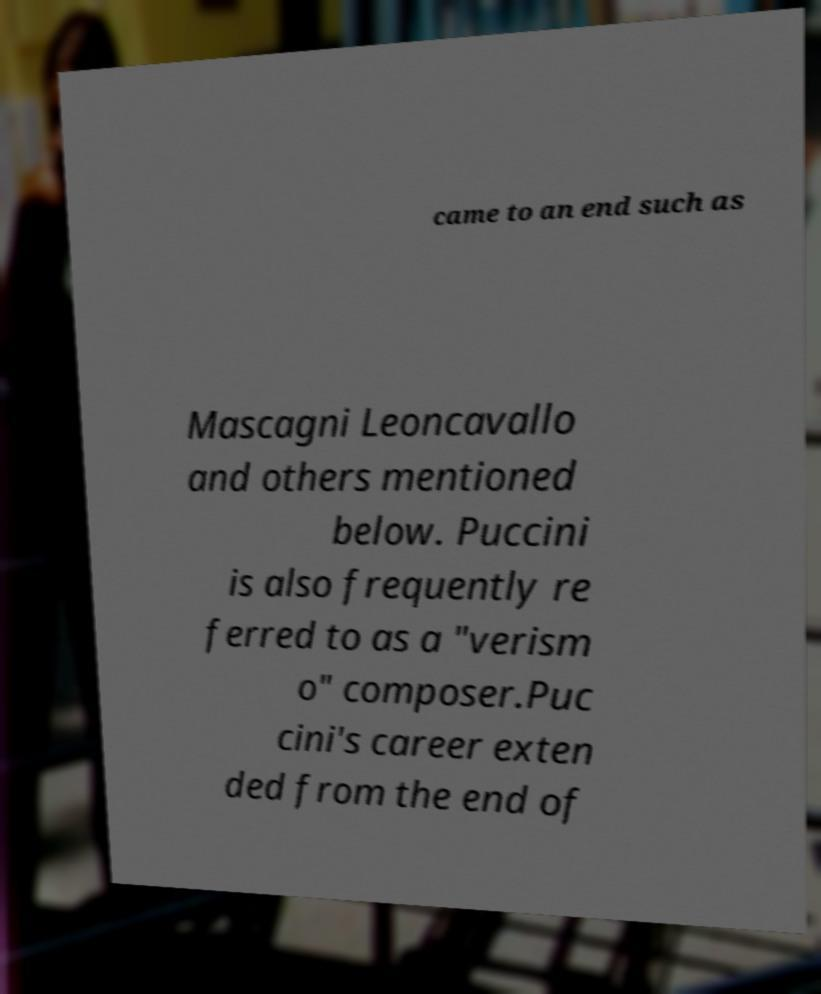Could you assist in decoding the text presented in this image and type it out clearly? came to an end such as Mascagni Leoncavallo and others mentioned below. Puccini is also frequently re ferred to as a "verism o" composer.Puc cini's career exten ded from the end of 